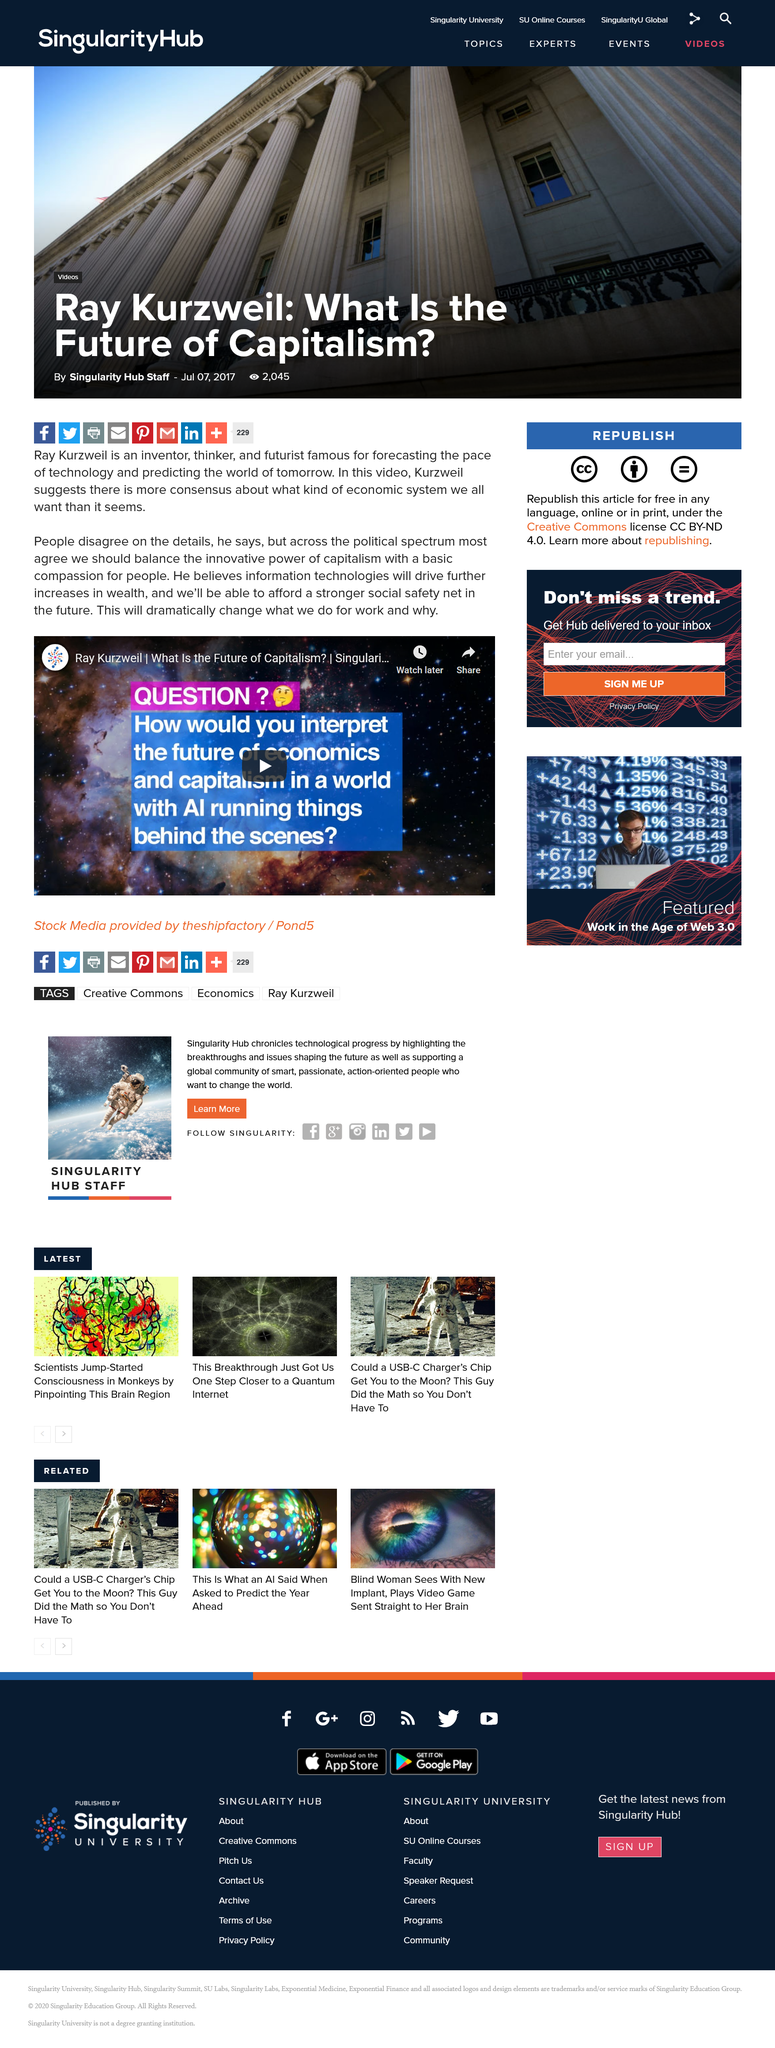Highlight a few significant elements in this photo. Ray Kurzweil is the one speaking in the video. In order to maintain the balance between innovation and compassion, it is crucial to ensure that the innovative power of capitalism is balanced with a basic compassion for people. Ray Kurzweil is renowned for forecasting the future, specifically predicting the world of tomorrow. 